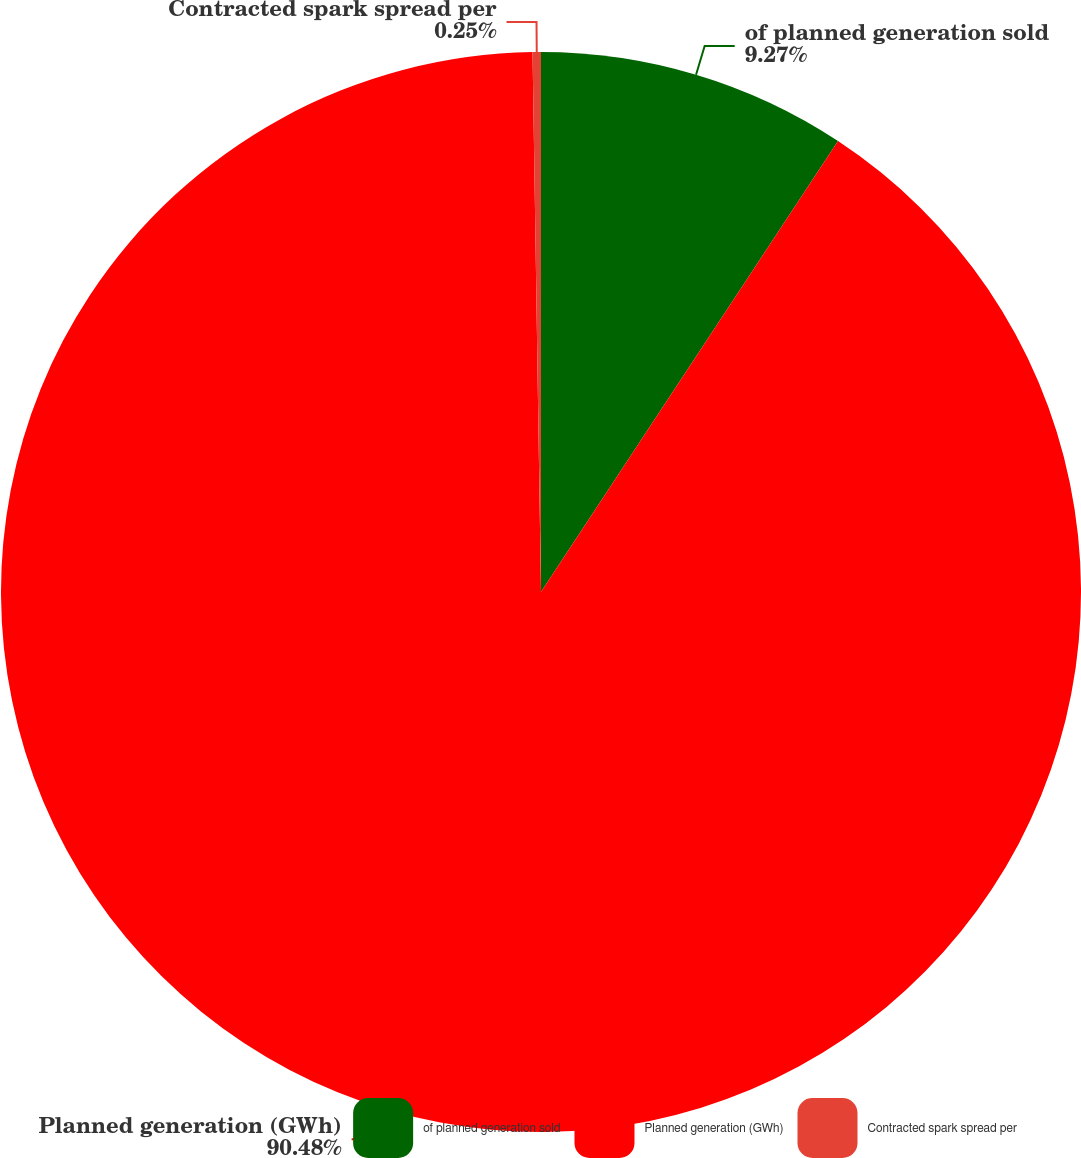Convert chart. <chart><loc_0><loc_0><loc_500><loc_500><pie_chart><fcel>of planned generation sold<fcel>Planned generation (GWh)<fcel>Contracted spark spread per<nl><fcel>9.27%<fcel>90.48%<fcel>0.25%<nl></chart> 